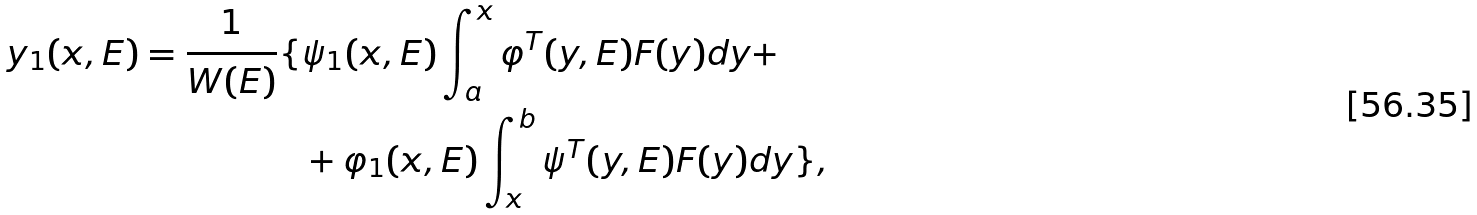Convert formula to latex. <formula><loc_0><loc_0><loc_500><loc_500>y _ { 1 } ( x , E ) = \frac { 1 } { W ( E ) } \{ & \psi _ { 1 } ( x , E ) \int ^ { x } _ { a } \varphi ^ { T } ( y , E ) F ( y ) d y + \\ & + \varphi _ { 1 } ( x , E ) \int ^ { b } _ { x } \psi ^ { T } ( y , E ) F ( y ) d y \} ,</formula> 